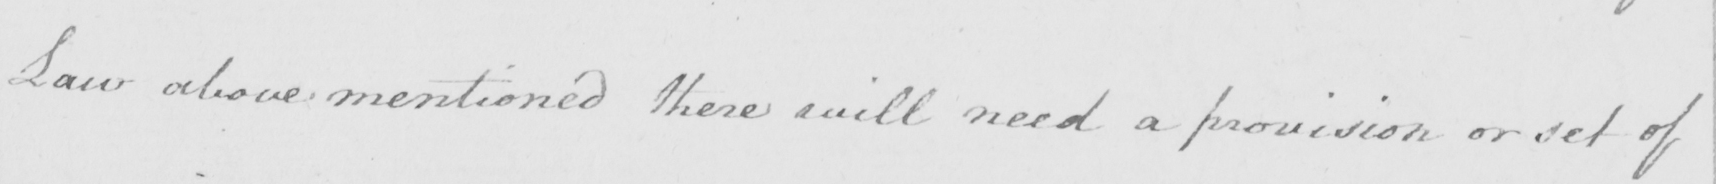Can you read and transcribe this handwriting? Law above mentioned there will need a provision or set of 